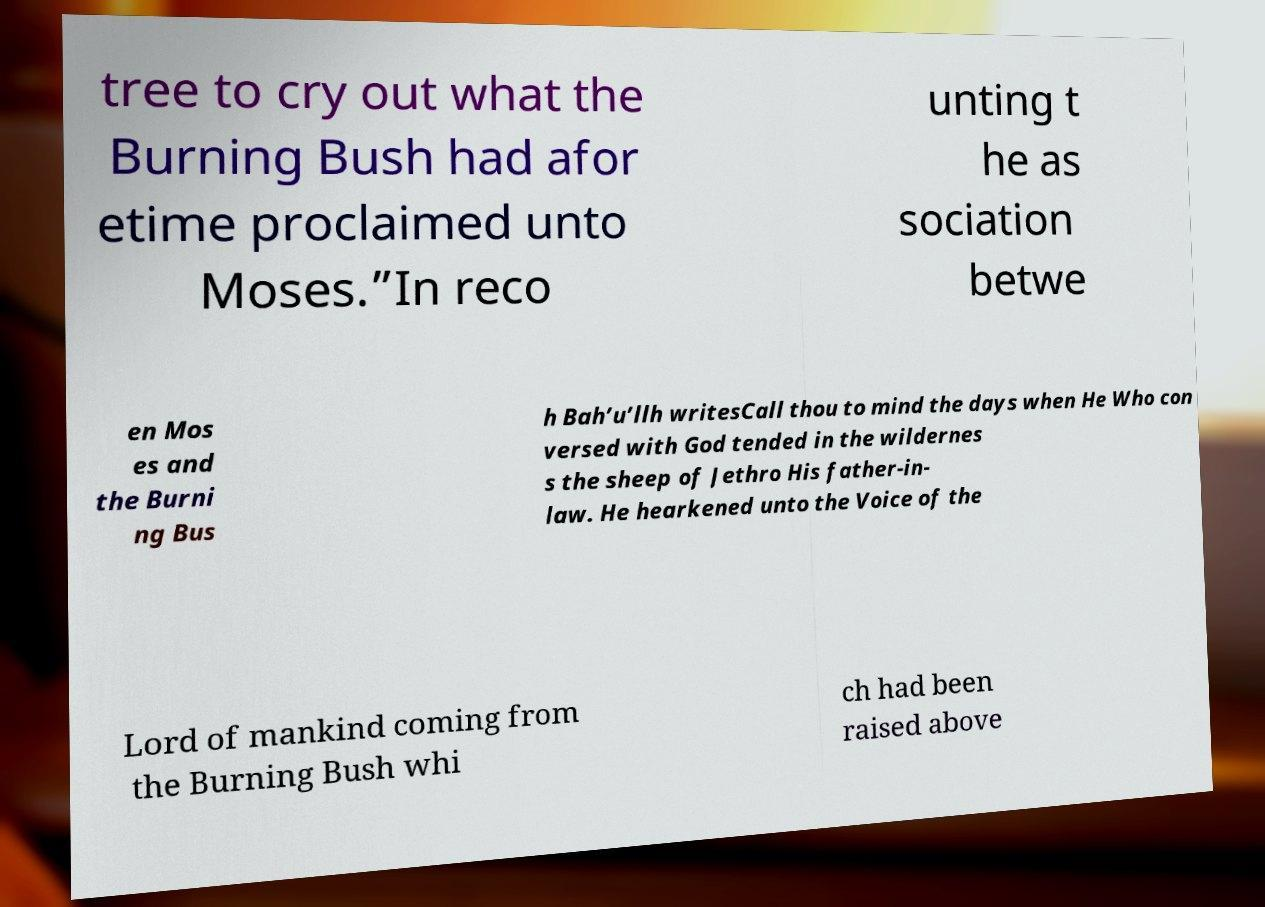Could you extract and type out the text from this image? tree to cry out what the Burning Bush had afor etime proclaimed unto Moses.”In reco unting t he as sociation betwe en Mos es and the Burni ng Bus h Bah’u’llh writesCall thou to mind the days when He Who con versed with God tended in the wildernes s the sheep of Jethro His father-in- law. He hearkened unto the Voice of the Lord of mankind coming from the Burning Bush whi ch had been raised above 